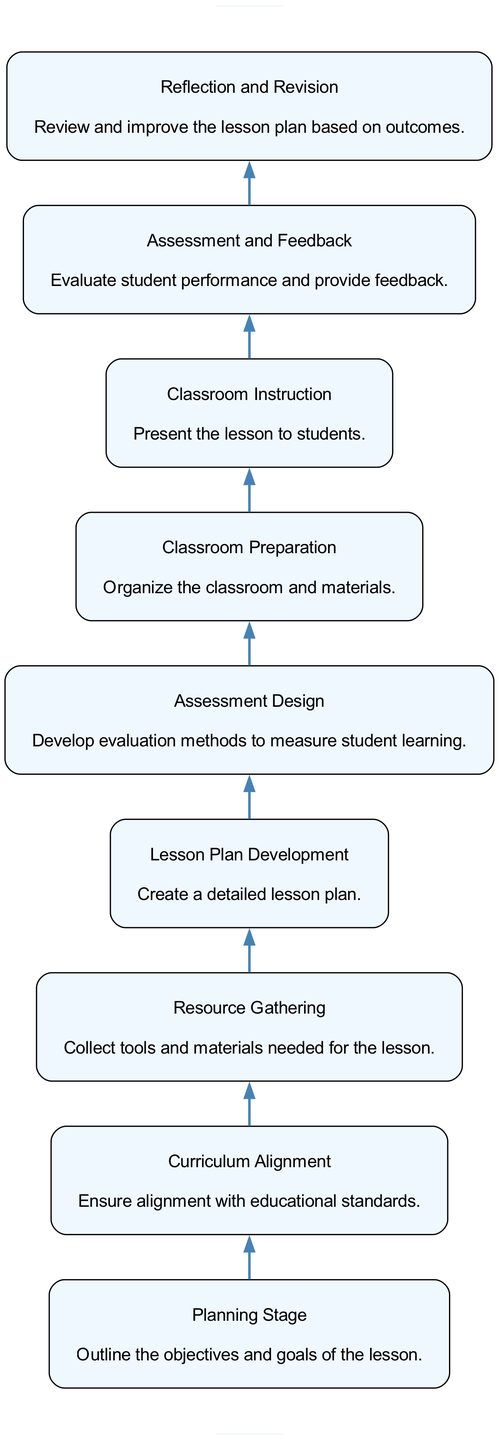What is the first step in the lifecycle of a science lesson plan? The first step, as shown in the diagram, is the "Planning Stage." This is indicated at the bottom of the flow chart and represents the starting point of the lesson preparation process.
Answer: Planning Stage How many nodes are present in the diagram? By counting all the distinct steps in the lifecycle presented in the diagram, there are a total of 9 nodes, representing different stages of the lesson plan.
Answer: 9 Which stage comes immediately after "Resource Gathering"? According to the flow of the diagram, "Lesson Plan Development" follows "Resource Gathering," indicating the next step after collecting materials and resources.
Answer: Lesson Plan Development What is the last phase of the lesson planning lifecycle? The last phase illustrated in the diagram is "Reflection and Revision," which signifies the endpoint where educators assess and improve the lesson plan based on feedback and results.
Answer: Reflection and Revision How are "Assessment Design" and "Classroom Preparation" related in the flow chart? In the flow chart, "Assessment Design" directly precedes "Classroom Preparation," indicating that after designing assessments for student understanding, the next step is to prepare the actual classroom for the lesson delivery.
Answer: Classroom Preparation What two stages are neighbors that focus on assessment? The two stages are "Assessment Design" and "Assessment and Feedback." These stages are adjacent in the flow chart and both relate to evaluating student understanding and performance.
Answer: Assessment Design and Assessment and Feedback Which step is concerned with organizing physical classrooms and equipment? The step that focuses on organizing and preparing the physical classroom and materials is "Classroom Preparation," as indicated in the diagram to ensure an effective learning environment.
Answer: Classroom Preparation What is the purpose of "Curriculum Alignment" in the lesson planning process? The purpose of "Curriculum Alignment" is to ensure that the lesson meets educational standards and benchmarks, which is essential for creating an effective educational experience for students.
Answer: Ensure alignment with educational standards What comes before "Classroom Instruction"? The step preceding "Classroom Instruction" is "Classroom Preparation," which emphasizes organizing materials and the classroom environment before delivering the lesson to students.
Answer: Classroom Preparation 